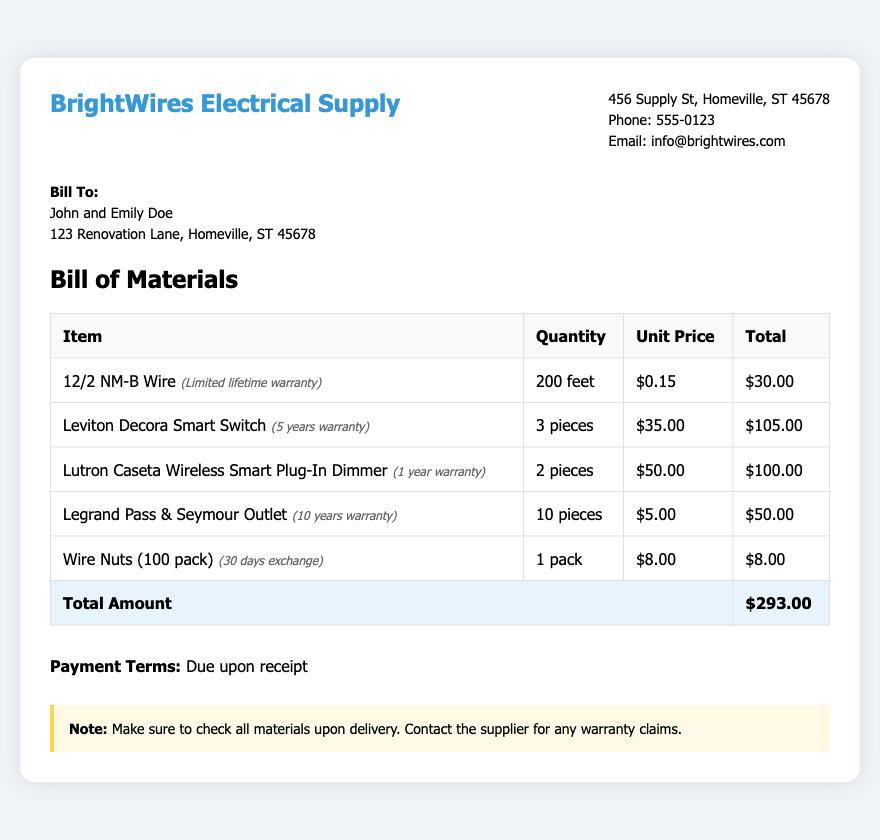What is the name of the supplier? The supplier's name is provided in the header section of the bill.
Answer: BrightWires Electrical Supply What is the total amount due? The total amount due is calculated from all items listed in the bill.
Answer: $293.00 How many pieces of the Decora Smart Switch are purchased? The quantity of the Decora Smart Switch is listed in the bill of materials under the relevant item.
Answer: 3 pieces What is the warranty period for the Leviton Decora Smart Switch? The warranty information is noted next to the item in the bill.
Answer: 5 years Where is the supplier located? The supplier's address is detailed in the supplier info section of the bill.
Answer: 456 Supply St, Homeville, ST 45678 What is the unit price for Wire Nuts? The unit price is specified in the table of items in the bill.
Answer: $8.00 What payment terms are stated in the document? The payment terms are outlined clearly at the bottom of the document.
Answer: Due upon receipt What is the warranty for the Wire Nuts? The warranty conditions are mentioned next to the item in the table.
Answer: 30 days exchange How many feet of 12/2 NM-B Wire were purchased? The quantity of 12/2 NM-B Wire is listed in the bill of materials.
Answer: 200 feet 